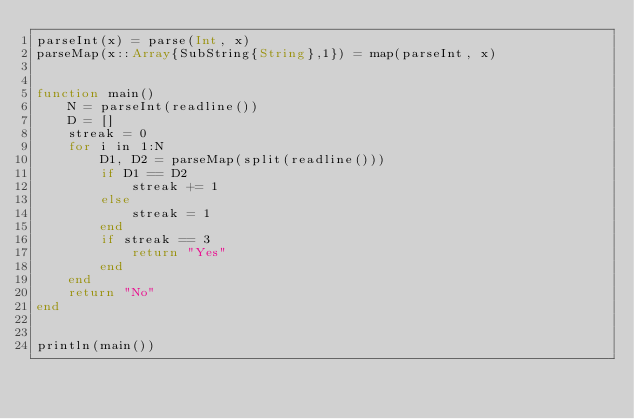<code> <loc_0><loc_0><loc_500><loc_500><_Julia_>parseInt(x) = parse(Int, x)
parseMap(x::Array{SubString{String},1}) = map(parseInt, x)


function main()
    N = parseInt(readline())
    D = []
    streak = 0
    for i in 1:N
        D1, D2 = parseMap(split(readline()))
        if D1 == D2
            streak += 1
        else
            streak = 1
        end
        if streak == 3
            return "Yes"
        end
    end
    return "No"
end


println(main())</code> 